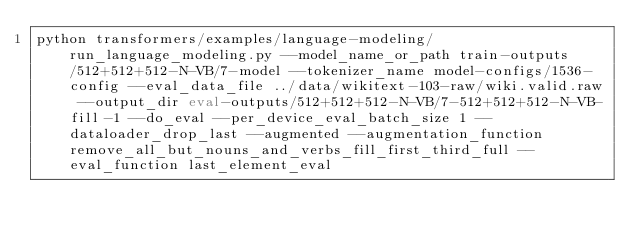Convert code to text. <code><loc_0><loc_0><loc_500><loc_500><_Bash_>python transformers/examples/language-modeling/run_language_modeling.py --model_name_or_path train-outputs/512+512+512-N-VB/7-model --tokenizer_name model-configs/1536-config --eval_data_file ../data/wikitext-103-raw/wiki.valid.raw --output_dir eval-outputs/512+512+512-N-VB/7-512+512+512-N-VB-fill-1 --do_eval --per_device_eval_batch_size 1 --dataloader_drop_last --augmented --augmentation_function remove_all_but_nouns_and_verbs_fill_first_third_full --eval_function last_element_eval</code> 